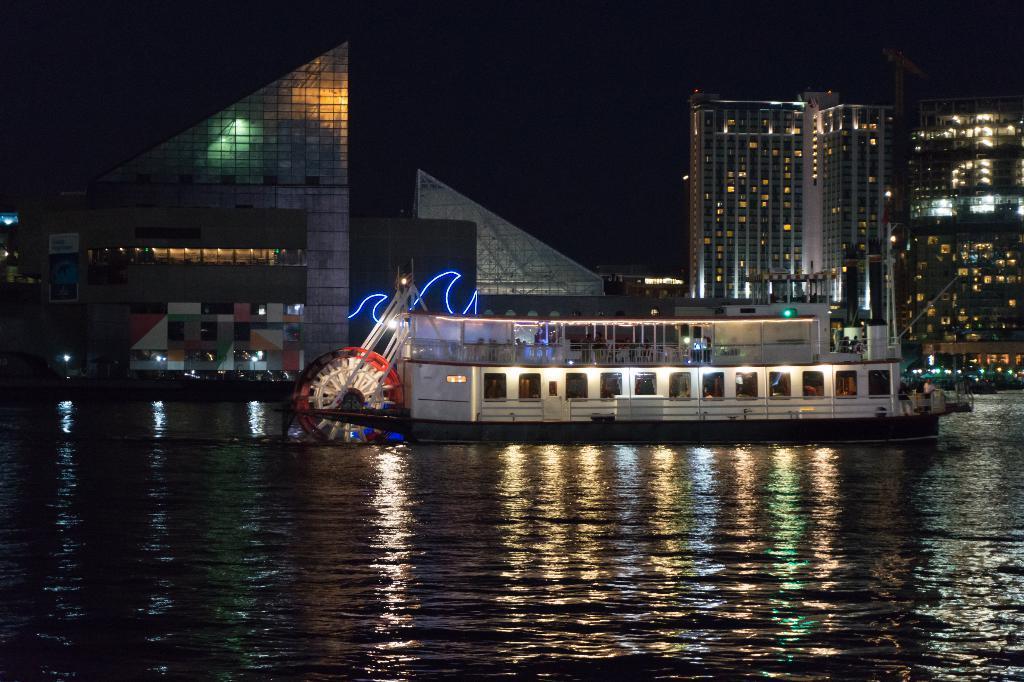How would you summarize this image in a sentence or two? In this picture we can see a boat on water, here we can see people, buildings, lights and some objects and in the background we can see it is dark. 